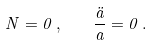<formula> <loc_0><loc_0><loc_500><loc_500>N = 0 \, , \quad \frac { \ddot { a } } { a } = 0 \, .</formula> 